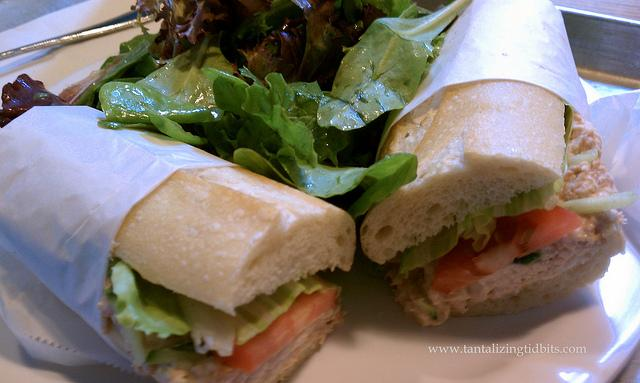What animal will most likely eat this meal?

Choices:
A) elephant
B) human
C) bird
D) cow human 